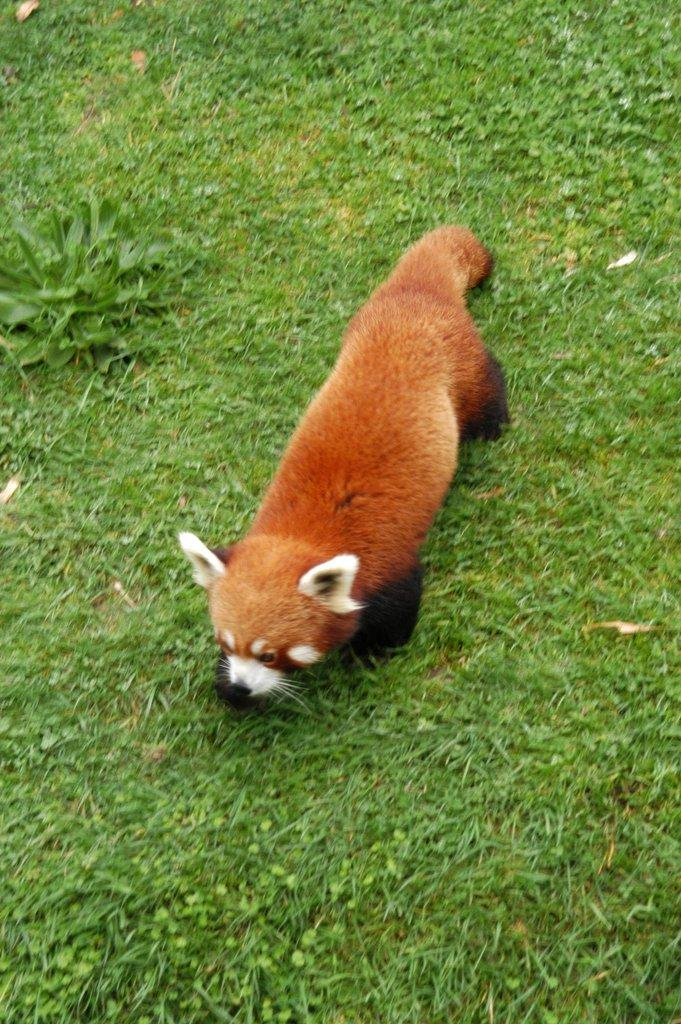What is the main subject in the middle of the image? There is an animal in the middle of the image. What type of environment is depicted at the bottom of the image? There is grass at the bottom of the image. What type of farm animal can be seen in the image? There is no farm animal present in the image. Can you describe the beast that is attacking the animal in the image? There is no beast or any attack depicted in the image; it only shows an animal and grass. 